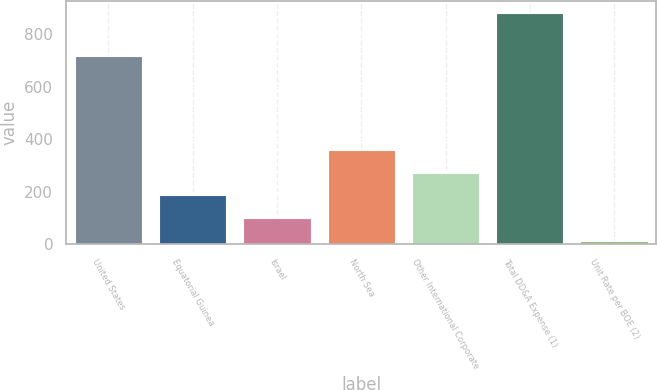<chart> <loc_0><loc_0><loc_500><loc_500><bar_chart><fcel>United States<fcel>Equatorial Guinea<fcel>Israel<fcel>North Sea<fcel>Other International Corporate<fcel>Total DD&A Expense (1)<fcel>Unit Rate per BOE (2)<nl><fcel>719<fcel>185.85<fcel>98.71<fcel>360.13<fcel>272.99<fcel>883<fcel>11.57<nl></chart> 